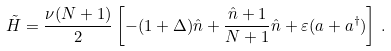<formula> <loc_0><loc_0><loc_500><loc_500>\tilde { H } = \frac { \nu ( N + 1 ) } { 2 } \left [ - ( 1 + \Delta ) \hat { n } + \frac { \hat { n } + 1 } { N + 1 } \hat { n } + \varepsilon ( a + a ^ { \dagger } ) \right ] \, .</formula> 